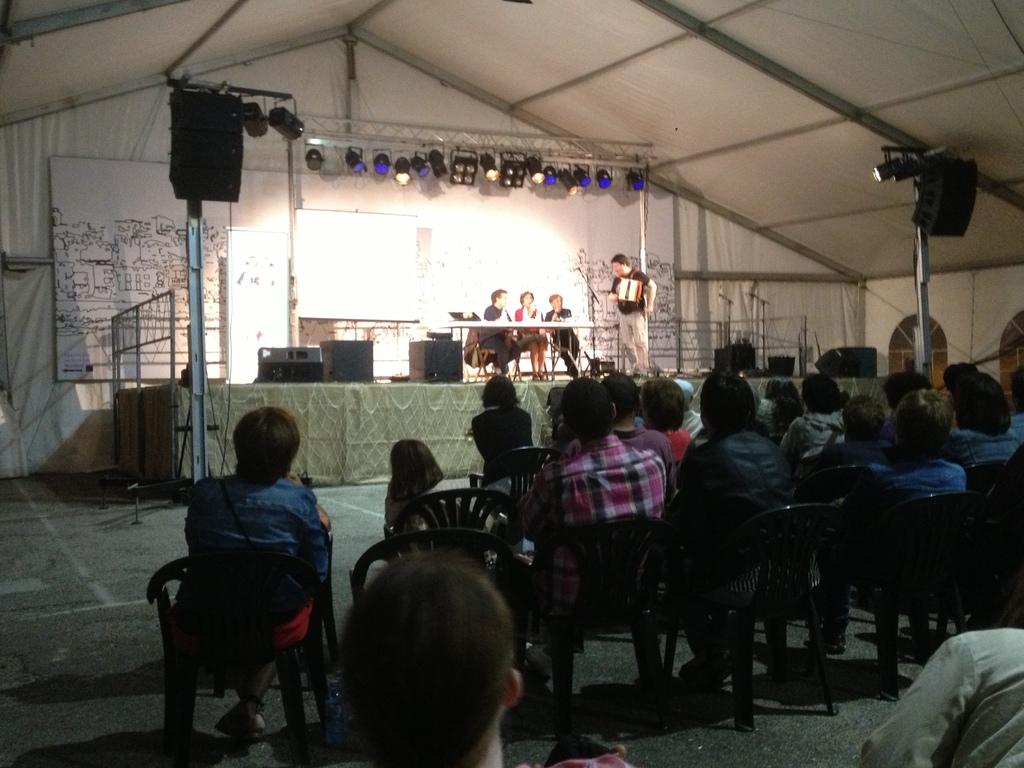What are the people in the image doing? There is a group of people sitting in the image. What can be seen in the background of the image? There is a tent and lights visible in the background of the image. What color is the tent in the image? The tent is white in color. What type of tin can be seen being used for basketball in the image? There is no tin or basketball present in the image. 